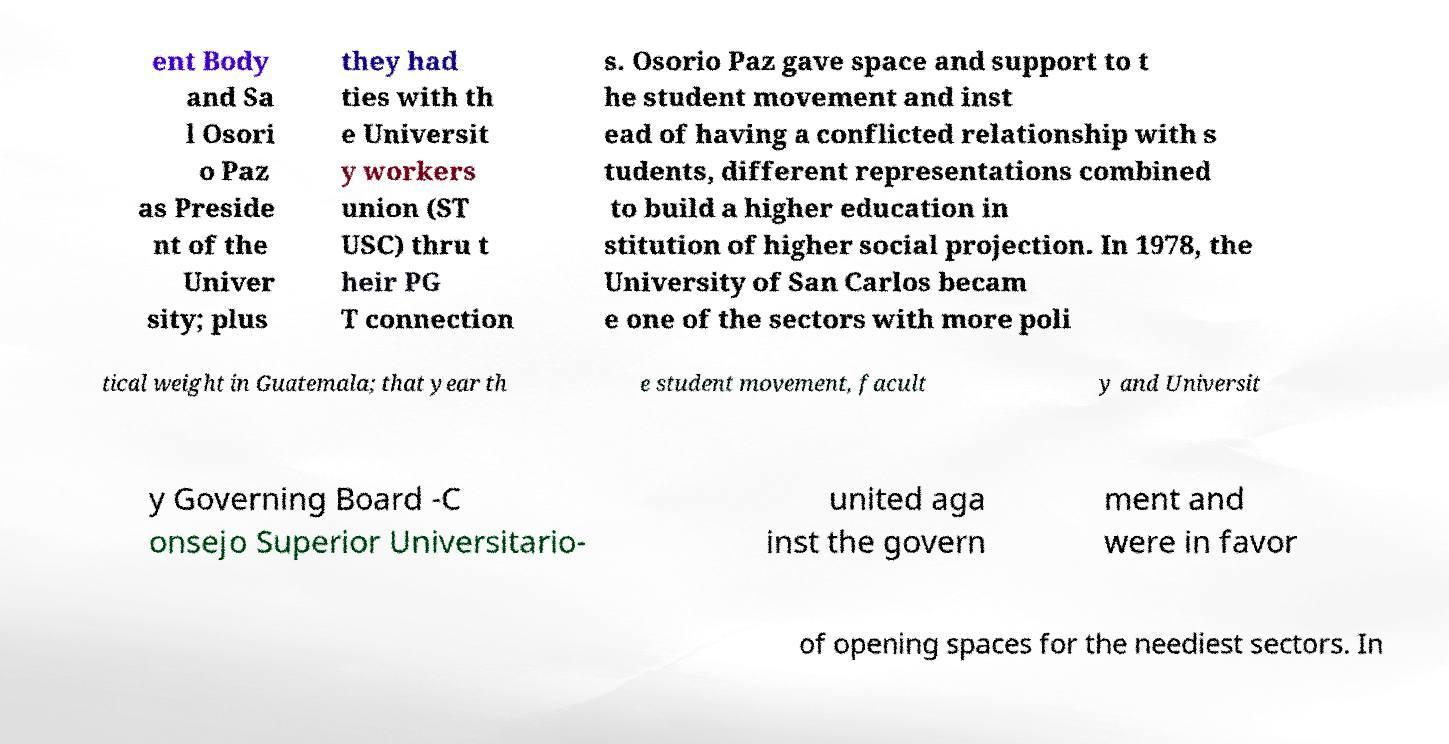Could you assist in decoding the text presented in this image and type it out clearly? ent Body and Sa l Osori o Paz as Preside nt of the Univer sity; plus they had ties with th e Universit y workers union (ST USC) thru t heir PG T connection s. Osorio Paz gave space and support to t he student movement and inst ead of having a conflicted relationship with s tudents, different representations combined to build a higher education in stitution of higher social projection. In 1978, the University of San Carlos becam e one of the sectors with more poli tical weight in Guatemala; that year th e student movement, facult y and Universit y Governing Board -C onsejo Superior Universitario- united aga inst the govern ment and were in favor of opening spaces for the neediest sectors. In 